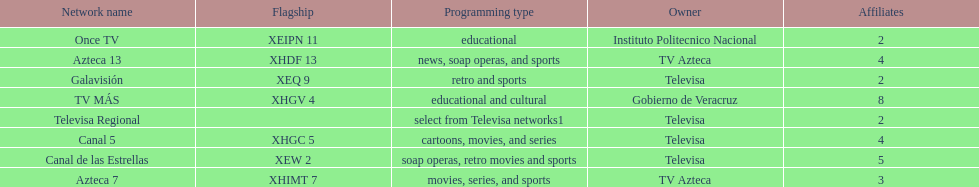Which is the only station with 8 affiliates? TV MÁS. 